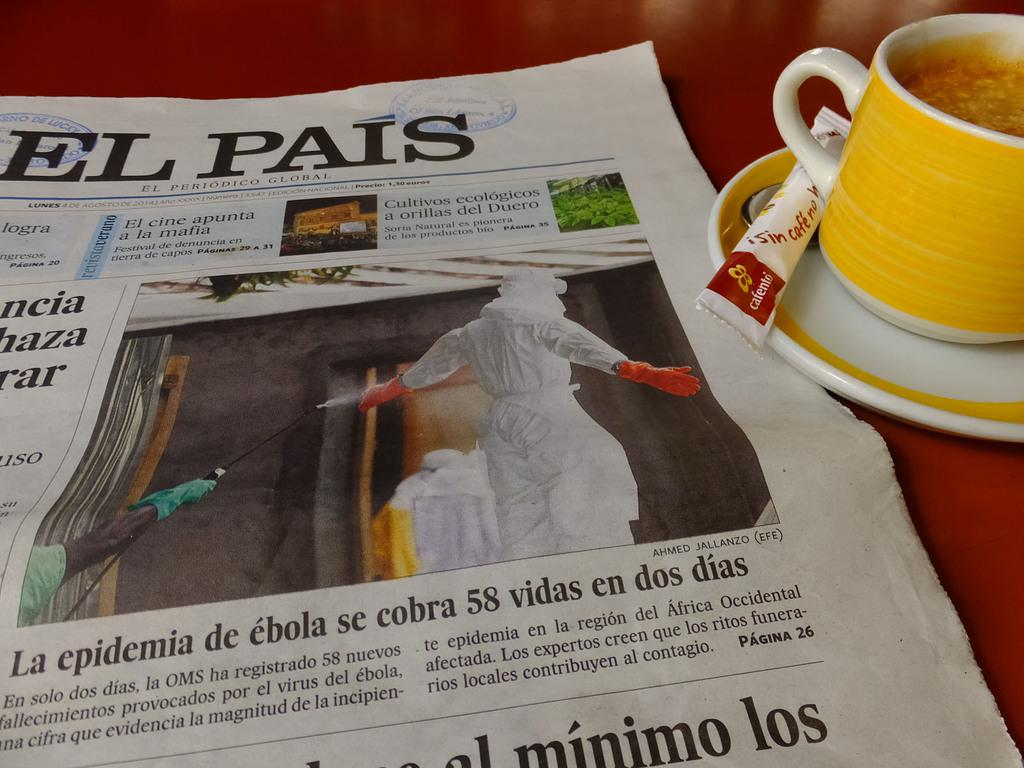What is the main object in the image? There is a newspaper in the image. What else can be seen on the table in the image? There is a sugar sachet, a spoon, a saucer, and a cup in the image. What is inside the cup? There is liquid in the image. What is the color of the surface in the image? The surface in the image is red. How many dolls are sitting on the table in the image? There are no dolls present in the image. What type of knife is being used to cut the lunch in the image? There is no knife or lunch present in the image. 